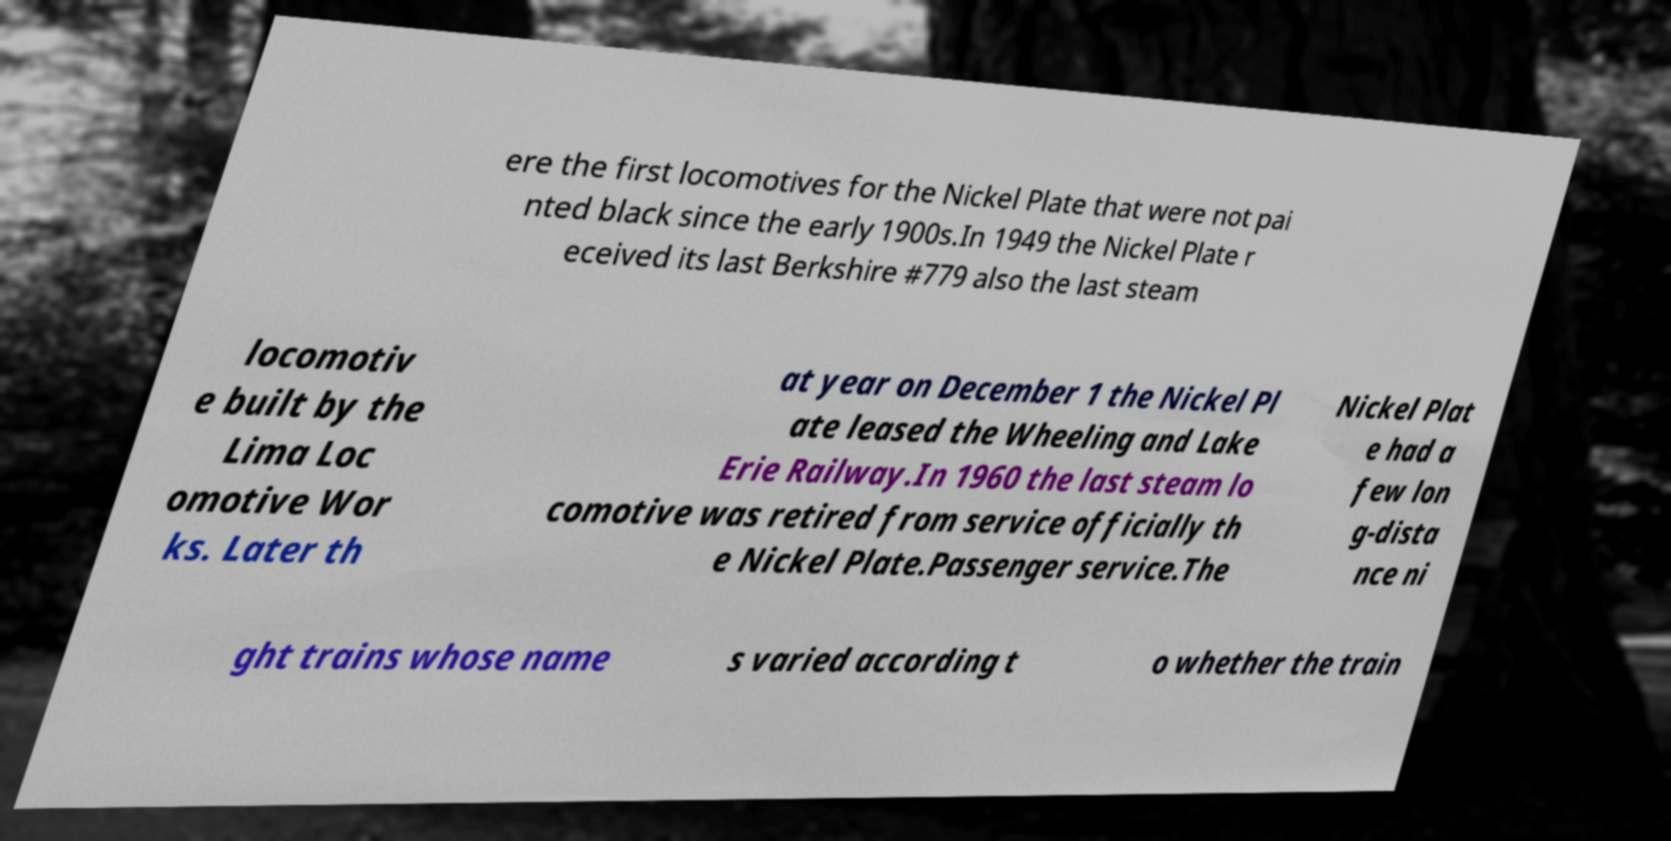Can you accurately transcribe the text from the provided image for me? ere the first locomotives for the Nickel Plate that were not pai nted black since the early 1900s.In 1949 the Nickel Plate r eceived its last Berkshire #779 also the last steam locomotiv e built by the Lima Loc omotive Wor ks. Later th at year on December 1 the Nickel Pl ate leased the Wheeling and Lake Erie Railway.In 1960 the last steam lo comotive was retired from service officially th e Nickel Plate.Passenger service.The Nickel Plat e had a few lon g-dista nce ni ght trains whose name s varied according t o whether the train 